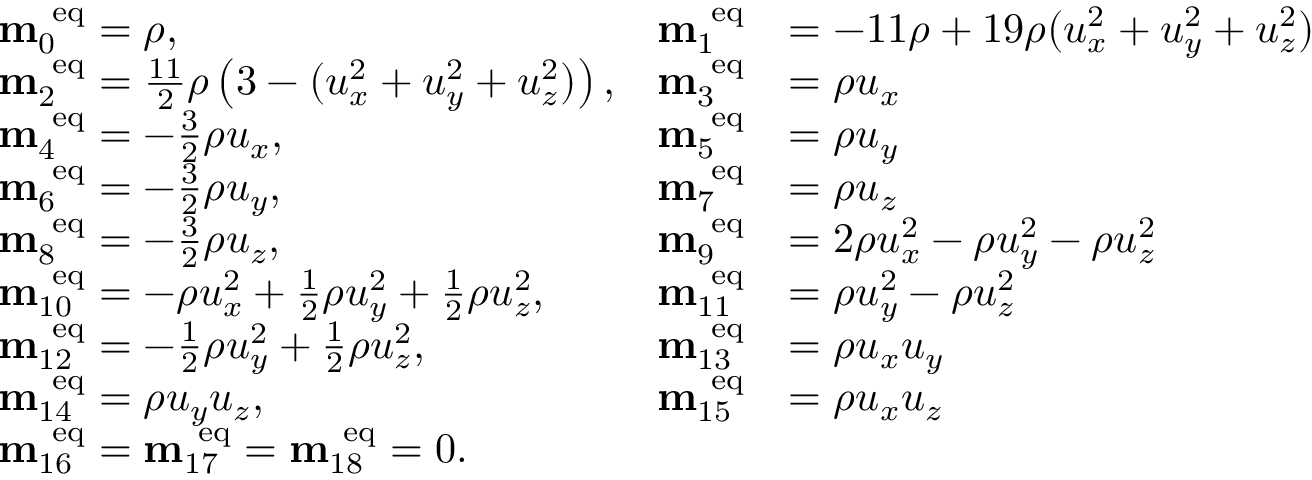Convert formula to latex. <formula><loc_0><loc_0><loc_500><loc_500>\begin{array} { r l r l } & { m _ { 0 } ^ { e q } = \rho , } & { m _ { 1 } ^ { e q } } & { = - 1 1 \rho + 1 9 \rho ( u _ { x } ^ { 2 } + u _ { y } ^ { 2 } + u _ { z } ^ { 2 } ) } \\ & { m _ { 2 } ^ { e q } = \frac { 1 1 } { 2 } \rho \left ( 3 - ( u _ { x } ^ { 2 } + u _ { y } ^ { 2 } + u _ { z } ^ { 2 } ) \right ) , } & { m _ { 3 } ^ { e q } } & { = \rho u _ { x } } \\ & { m _ { 4 } ^ { e q } = - \frac { 3 } { 2 } \rho u _ { x } , } & { m _ { 5 } ^ { e q } } & { = \rho u _ { y } } \\ & { m _ { 6 } ^ { e q } = - \frac { 3 } { 2 } \rho u _ { y } , } & { m _ { 7 } ^ { e q } } & { = \rho u _ { z } } \\ & { m _ { 8 } ^ { e q } = - \frac { 3 } { 2 } \rho u _ { z } , } & { m _ { 9 } ^ { e q } } & { = 2 \rho u _ { x } ^ { 2 } - \rho u _ { y } ^ { 2 } - \rho u _ { z } ^ { 2 } } \\ & { m _ { 1 0 } ^ { e q } = - \rho u _ { x } ^ { 2 } + \frac { 1 } { 2 } \rho u _ { y } ^ { 2 } + \frac { 1 } { 2 } \rho u _ { z } ^ { 2 } , } & { m _ { 1 1 } ^ { e q } } & { = \rho u _ { y } ^ { 2 } - \rho u _ { z } ^ { 2 } } \\ & { m _ { 1 2 } ^ { e q } = - \frac { 1 } { 2 } \rho u _ { y } ^ { 2 } + \frac { 1 } { 2 } \rho u _ { z } ^ { 2 } , } & { m _ { 1 3 } ^ { e q } } & { = \rho u _ { x } u _ { y } } \\ & { m _ { 1 4 } ^ { e q } = \rho u _ { y } u _ { z } , } & { m _ { 1 5 } ^ { e q } } & { = \rho u _ { x } u _ { z } } \\ & { m _ { 1 6 } ^ { e q } = m _ { 1 7 } ^ { e q } = m _ { 1 8 } ^ { e q } = 0 . } \end{array}</formula> 